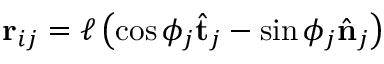<formula> <loc_0><loc_0><loc_500><loc_500>r _ { i j } = \ell \left ( \cos \phi _ { j } \hat { t } _ { j } - \sin \phi _ { j } \hat { n } _ { j } \right )</formula> 